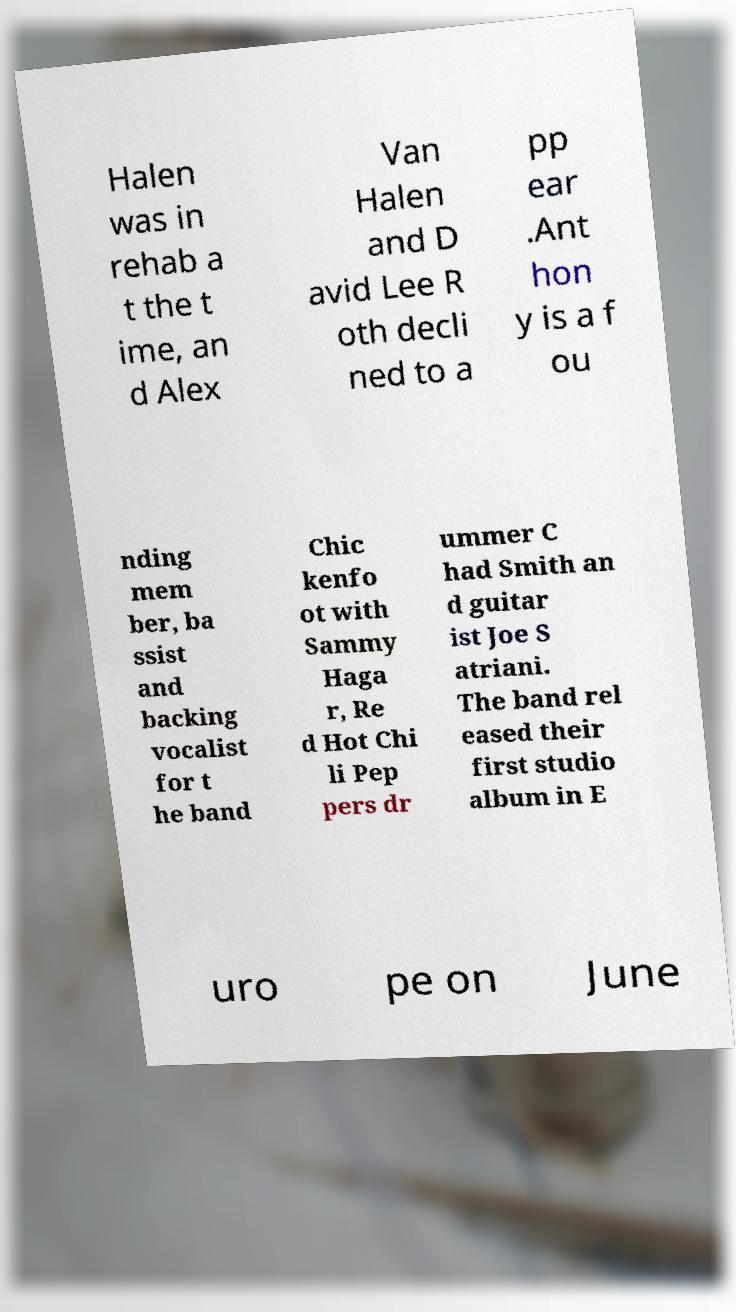What messages or text are displayed in this image? I need them in a readable, typed format. Halen was in rehab a t the t ime, an d Alex Van Halen and D avid Lee R oth decli ned to a pp ear .Ant hon y is a f ou nding mem ber, ba ssist and backing vocalist for t he band Chic kenfo ot with Sammy Haga r, Re d Hot Chi li Pep pers dr ummer C had Smith an d guitar ist Joe S atriani. The band rel eased their first studio album in E uro pe on June 